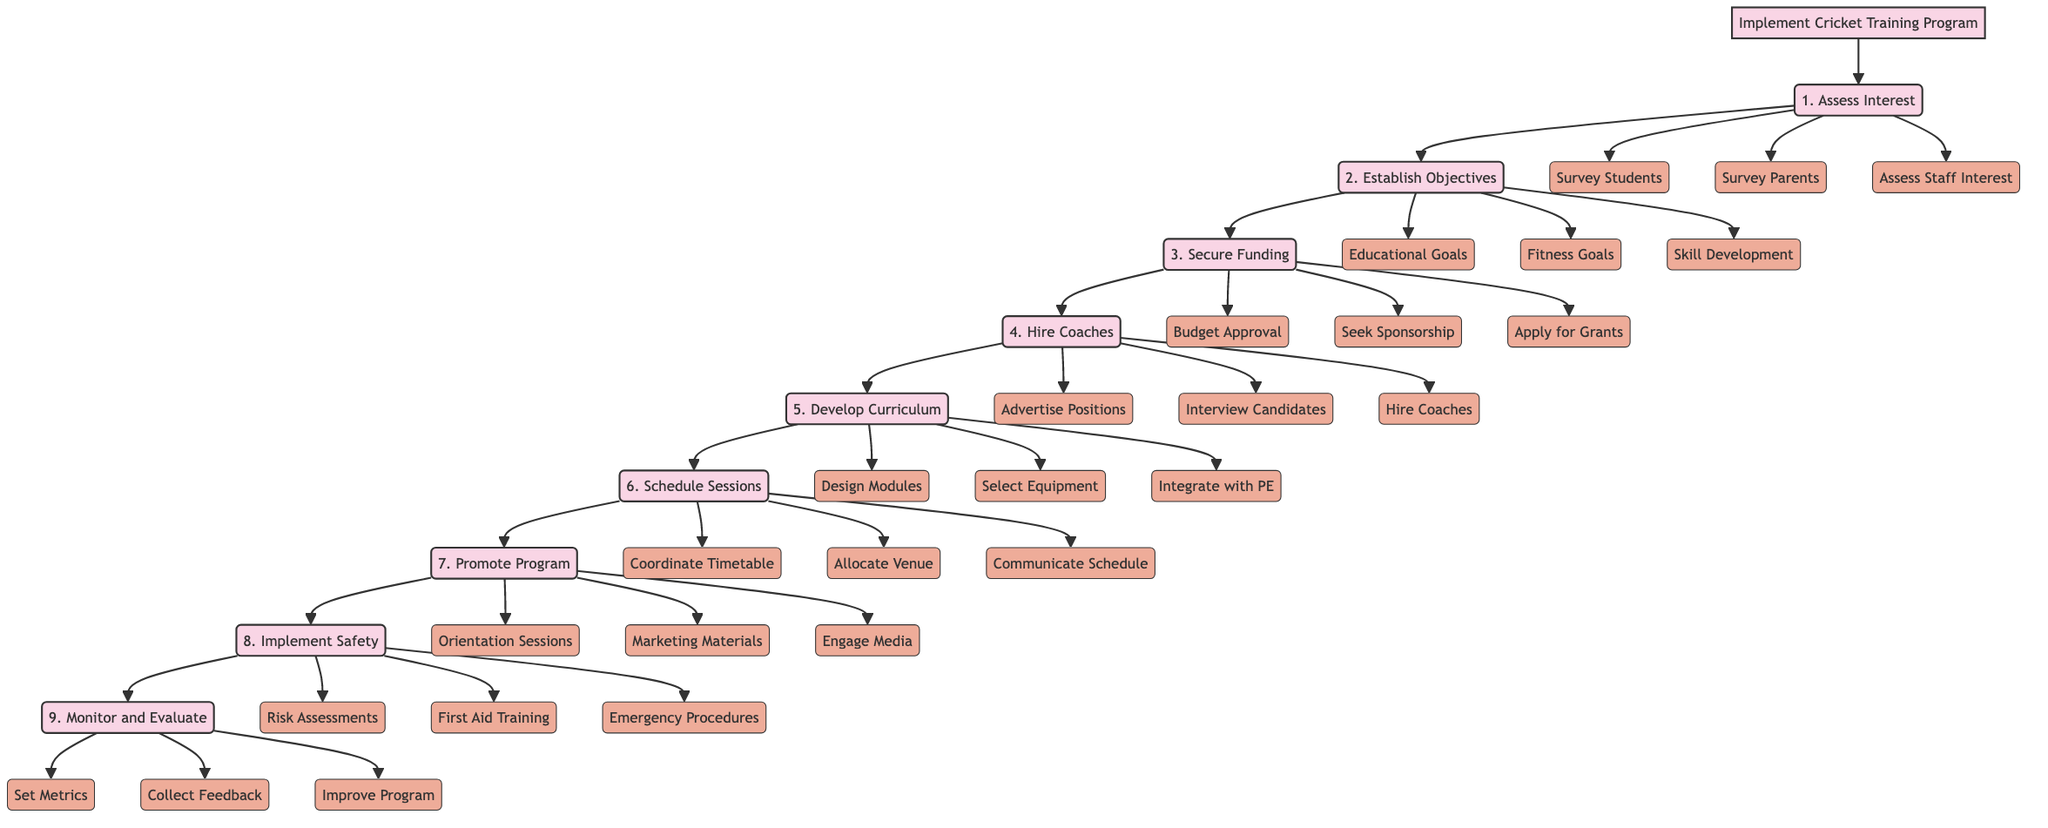What is the first step in the diagram? The first step in the flowchart is labeled "1. Assess Interest". This is the initial action to determine if there is student interest in the cricket training program.
Answer: 1. Assess Interest How many main steps are there in the implementation process? The flowchart lists a total of nine main steps from "1. Assess Interest" to "9. Monitor and Evaluate". By counting these main steps, we find that there are nine.
Answer: 9 What is step four in the implementation of the cricket training program? Step four is labeled "4. Hire Qualified Coaches". This step focuses on recruiting suitable coaches for the training program.
Answer: 4. Hire Qualified Coaches Which sub-step is included under scheduling training sessions? One of the sub-steps under scheduling training sessions is "Allocate Venue and Facilities". This indicates the need to secure appropriate locations for training.
Answer: Allocate Venue and Facilities What steps involve securing funding? Steps involving securing funding include "3. Secure Funding and Resources". This encompasses obtaining budget approval, sponsorships, and grants necessary for the program.
Answer: 3. Secure Funding and Resources What should be done before hiring coaches according to the diagram? Before hiring coaches, the diagram indicates that the position needs to be "Advertise Coaching Positions". This step is crucial for attracting qualified candidates.
Answer: Advertise Coaching Positions What are the three areas defined in the program objectives? The program objectives are defined in three areas: "Educational Goals", "Physical Fitness Goals", and "Skill Development Goals". These focus on holistic development through cricket.
Answer: Educational Goals, Physical Fitness Goals, Skill Development Goals Which step involves reviewing performance metrics? The step that involves reviewing performance metrics is "9. Monitor and Evaluate Program". This step assesses the success of the training program and encourages improvements based on feedback.
Answer: 9. Monitor and Evaluate Program What is the final step in the implementation process? The final step in the flowchart is "9. Monitor and Evaluate". This step concludes the process by ensuring ongoing assessment and enhancement of the program.
Answer: 9. Monitor and Evaluate 